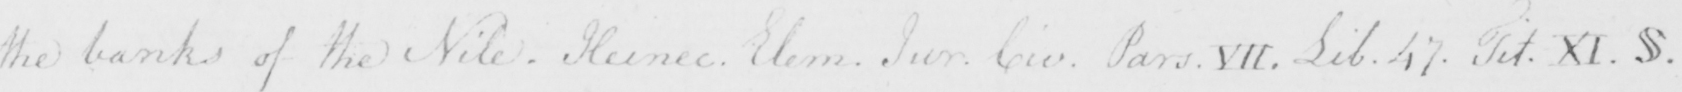What text is written in this handwritten line? the banks of the Nile . Heinec . Elem . Sur . Civ . Pars . VII . Lib . 47 . Tit . XI .  § . 